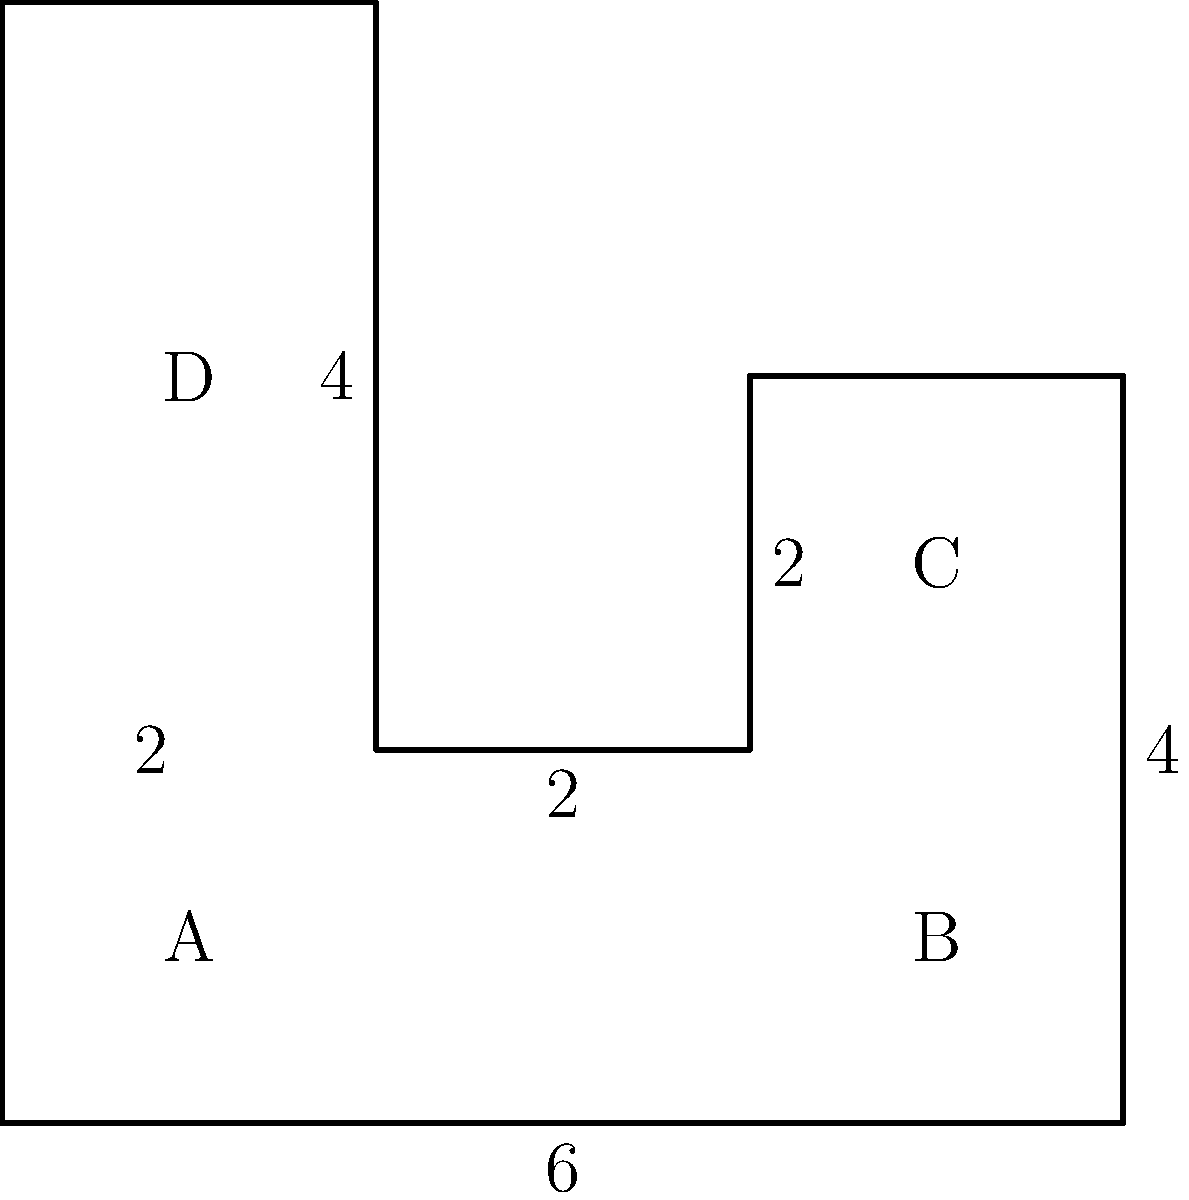Given the complex shape above composed of rectangles and triangles, calculate its total area. All measurements are in meters. Let's break this down step-by-step:

1) First, we'll divide the shape into four areas: A, B, C, and D.

2) Area A: This is a 2m × 2m square.
   $A_A = 2m \times 2m = 4m^2$

3) Area B: This is a 4m × 2m rectangle.
   $A_B = 4m \times 2m = 8m^2$

4) Area C: This is a 2m × 2m square.
   $A_C = 2m \times 2m = 4m^2$

5) Area D: This is a 2m × 4m rectangle.
   $A_D = 2m \times 4m = 8m^2$

6) The total area is the sum of all these areas:
   $A_{total} = A_A + A_B + A_C + A_D$
   $A_{total} = 4m^2 + 8m^2 + 4m^2 + 8m^2 = 24m^2$

Therefore, the total area of the complex shape is 24 square meters.
Answer: $24m^2$ 